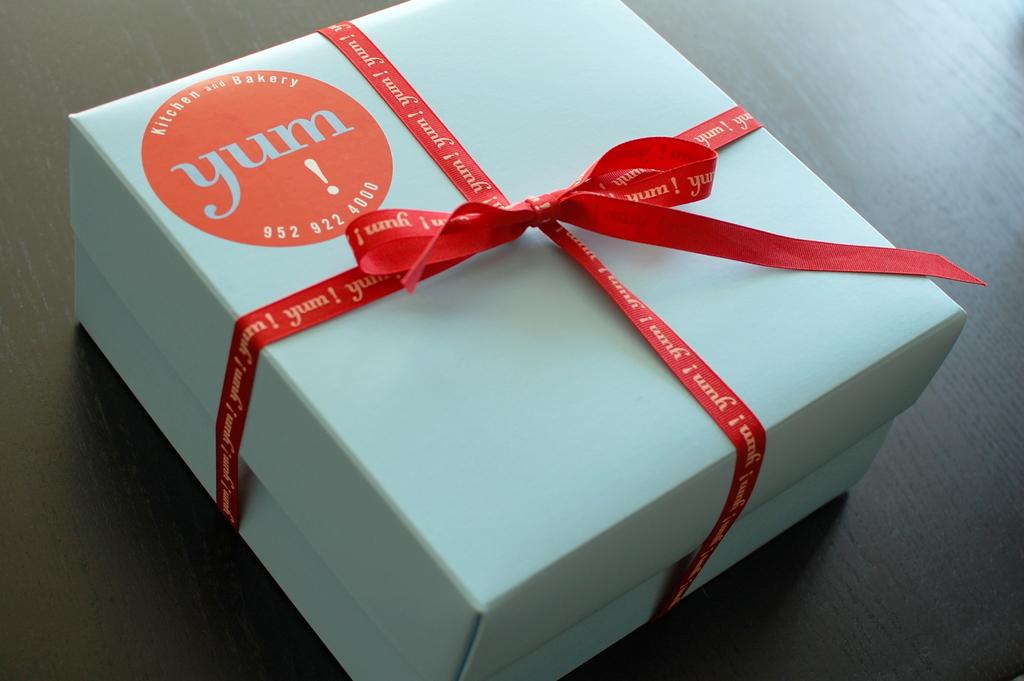What is the phone number on the sticker?
Your answer should be compact. 952-922-4000. 